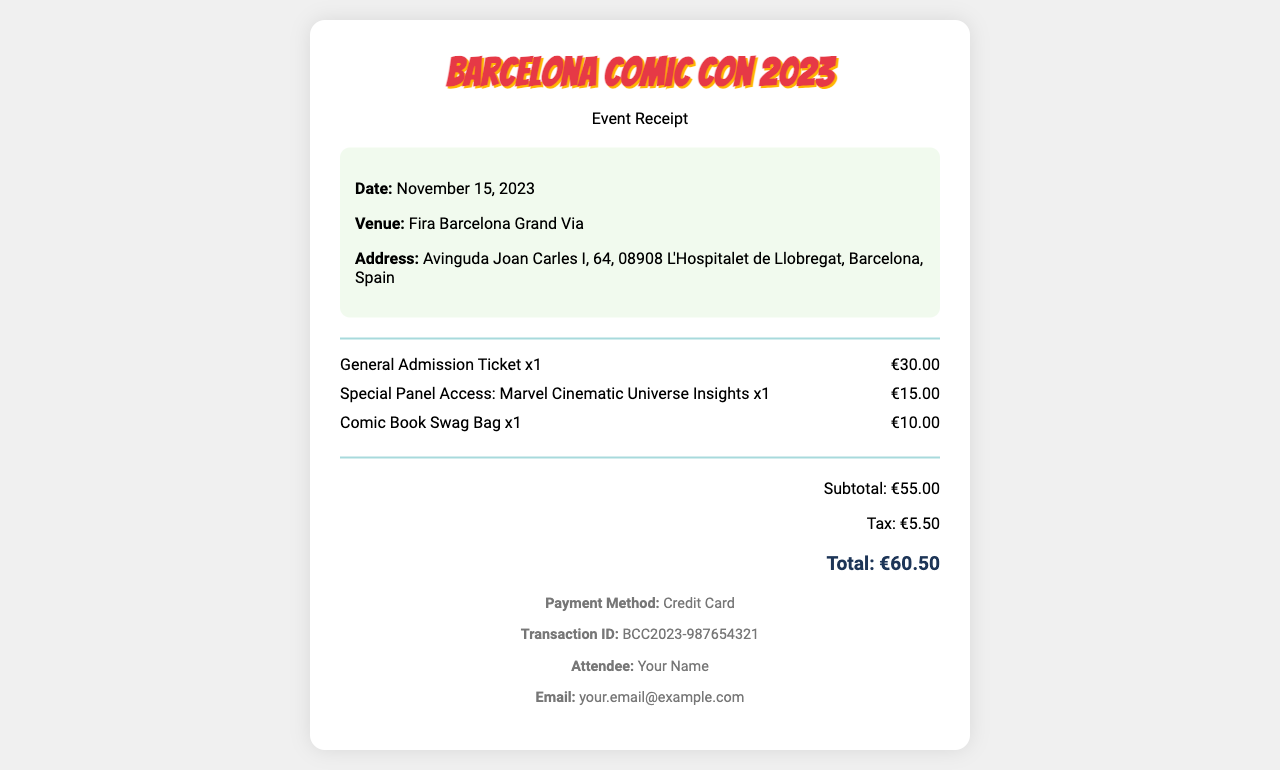what is the date of the event? The date of the event is specified in the document header under event info.
Answer: November 15, 2023 what is the venue for the comic convention? The venue is mentioned in the document under event info.
Answer: Fira Barcelona Grand Via how much is the general admission ticket? The price for the general admission ticket is detailed in the items section of the receipt.
Answer: €30.00 what is the total amount charged for the tickets and access? The total amount is calculated from the subtotal and tax provided in the totals section.
Answer: €60.50 how much does the special panel access cost? The cost of the special panel access is listed in the items section specifically for that item.
Answer: €15.00 what method of payment was used? The payment method is specified in the footer of the receipt.
Answer: Credit Card what is the email address on the receipt? The email address is provided in the footer section as the contact information for the attendee.
Answer: your.email@example.com how many items were purchased in total? The total number of items is counted from the items section, where each item listed can be summed.
Answer: 3 